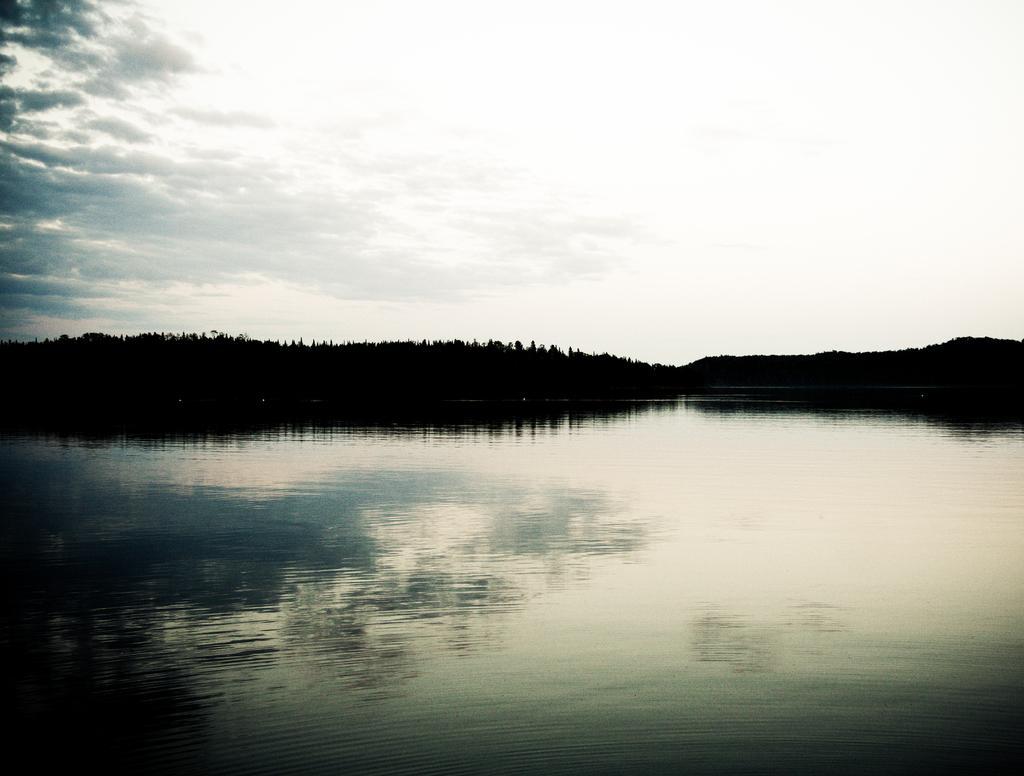Please provide a concise description of this image. In the center of the image there is a lake. In the background there are trees and sky. 